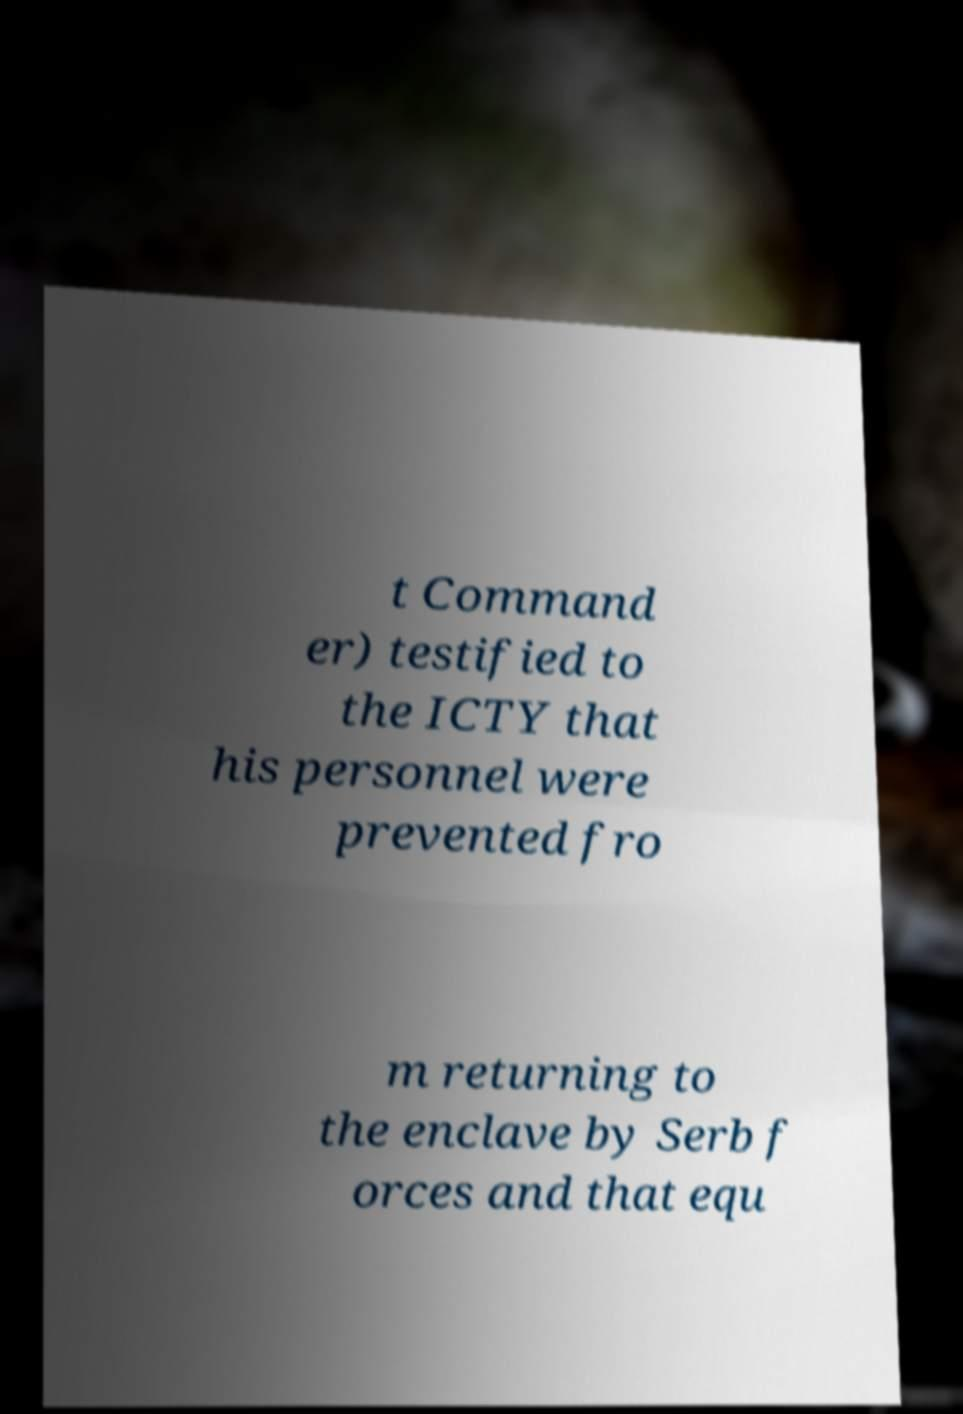Please read and relay the text visible in this image. What does it say? t Command er) testified to the ICTY that his personnel were prevented fro m returning to the enclave by Serb f orces and that equ 